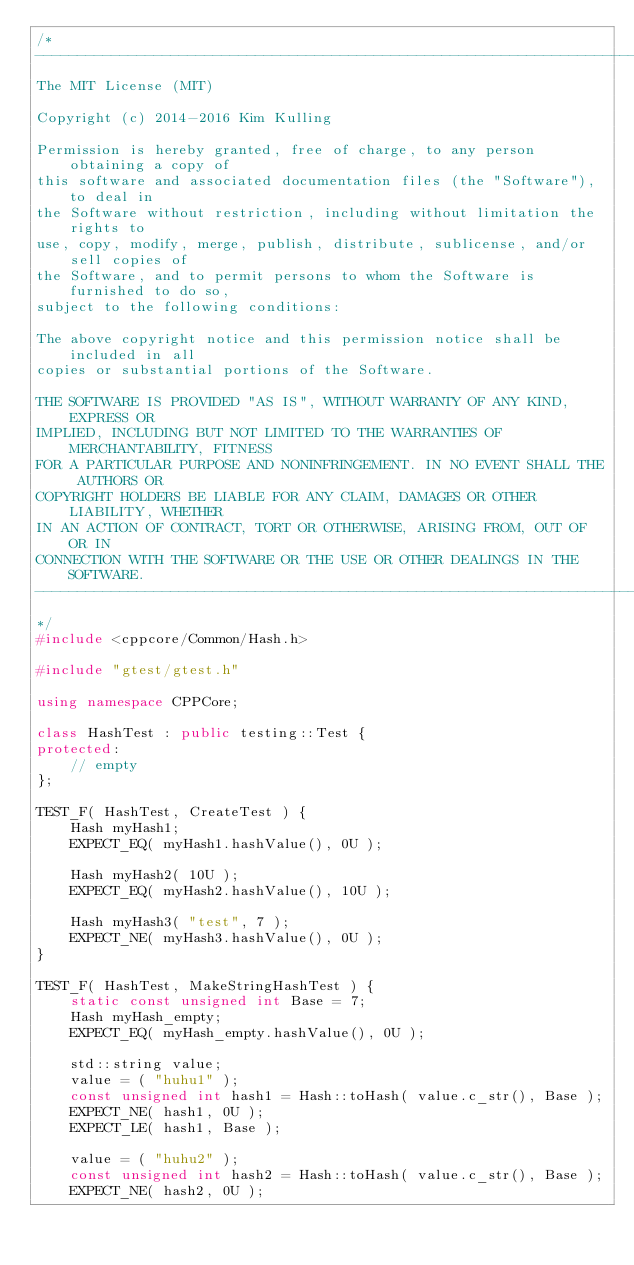<code> <loc_0><loc_0><loc_500><loc_500><_C++_>/*
-------------------------------------------------------------------------------------------------
The MIT License (MIT)

Copyright (c) 2014-2016 Kim Kulling

Permission is hereby granted, free of charge, to any person obtaining a copy of
this software and associated documentation files (the "Software"), to deal in
the Software without restriction, including without limitation the rights to
use, copy, modify, merge, publish, distribute, sublicense, and/or sell copies of
the Software, and to permit persons to whom the Software is furnished to do so,
subject to the following conditions:

The above copyright notice and this permission notice shall be included in all
copies or substantial portions of the Software.

THE SOFTWARE IS PROVIDED "AS IS", WITHOUT WARRANTY OF ANY KIND, EXPRESS OR
IMPLIED, INCLUDING BUT NOT LIMITED TO THE WARRANTIES OF MERCHANTABILITY, FITNESS
FOR A PARTICULAR PURPOSE AND NONINFRINGEMENT. IN NO EVENT SHALL THE AUTHORS OR
COPYRIGHT HOLDERS BE LIABLE FOR ANY CLAIM, DAMAGES OR OTHER LIABILITY, WHETHER
IN AN ACTION OF CONTRACT, TORT OR OTHERWISE, ARISING FROM, OUT OF OR IN
CONNECTION WITH THE SOFTWARE OR THE USE OR OTHER DEALINGS IN THE SOFTWARE.
-------------------------------------------------------------------------------------------------
*/
#include <cppcore/Common/Hash.h>

#include "gtest/gtest.h"

using namespace CPPCore;

class HashTest : public testing::Test {
protected:
    // empty
};

TEST_F( HashTest, CreateTest ) {
    Hash myHash1;
    EXPECT_EQ( myHash1.hashValue(), 0U );

    Hash myHash2( 10U );
    EXPECT_EQ( myHash2.hashValue(), 10U );

    Hash myHash3( "test", 7 );
    EXPECT_NE( myHash3.hashValue(), 0U );
}

TEST_F( HashTest, MakeStringHashTest ) {
    static const unsigned int Base = 7;
    Hash myHash_empty;
    EXPECT_EQ( myHash_empty.hashValue(), 0U );
    
    std::string value;
    value = ( "huhu1" );
    const unsigned int hash1 = Hash::toHash( value.c_str(), Base );
    EXPECT_NE( hash1, 0U );
    EXPECT_LE( hash1, Base );

    value = ( "huhu2" );
    const unsigned int hash2 = Hash::toHash( value.c_str(), Base );
    EXPECT_NE( hash2, 0U );</code> 